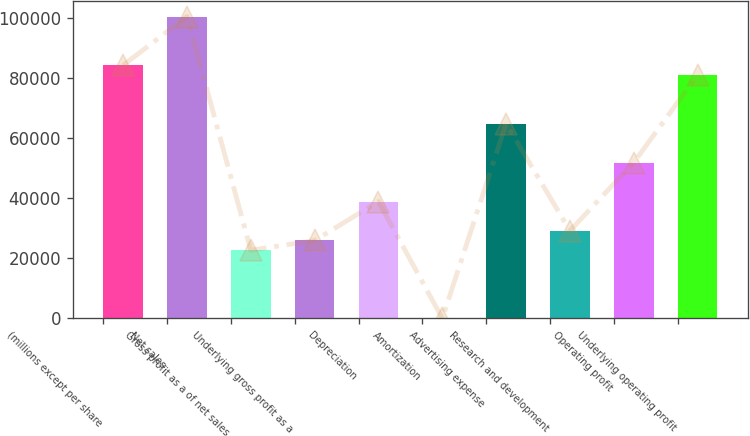Convert chart to OTSL. <chart><loc_0><loc_0><loc_500><loc_500><bar_chart><fcel>(millions except per share<fcel>Net sales<fcel>Gross profit as a of net sales<fcel>Underlying gross profit as a<fcel>Depreciation<fcel>Amortization<fcel>Advertising expense<fcel>Research and development<fcel>Operating profit<fcel>Underlying operating profit<nl><fcel>84222.8<fcel>100419<fcel>22676.1<fcel>25915.4<fcel>38872.6<fcel>1<fcel>64787<fcel>29154.7<fcel>51829.8<fcel>80983.5<nl></chart> 